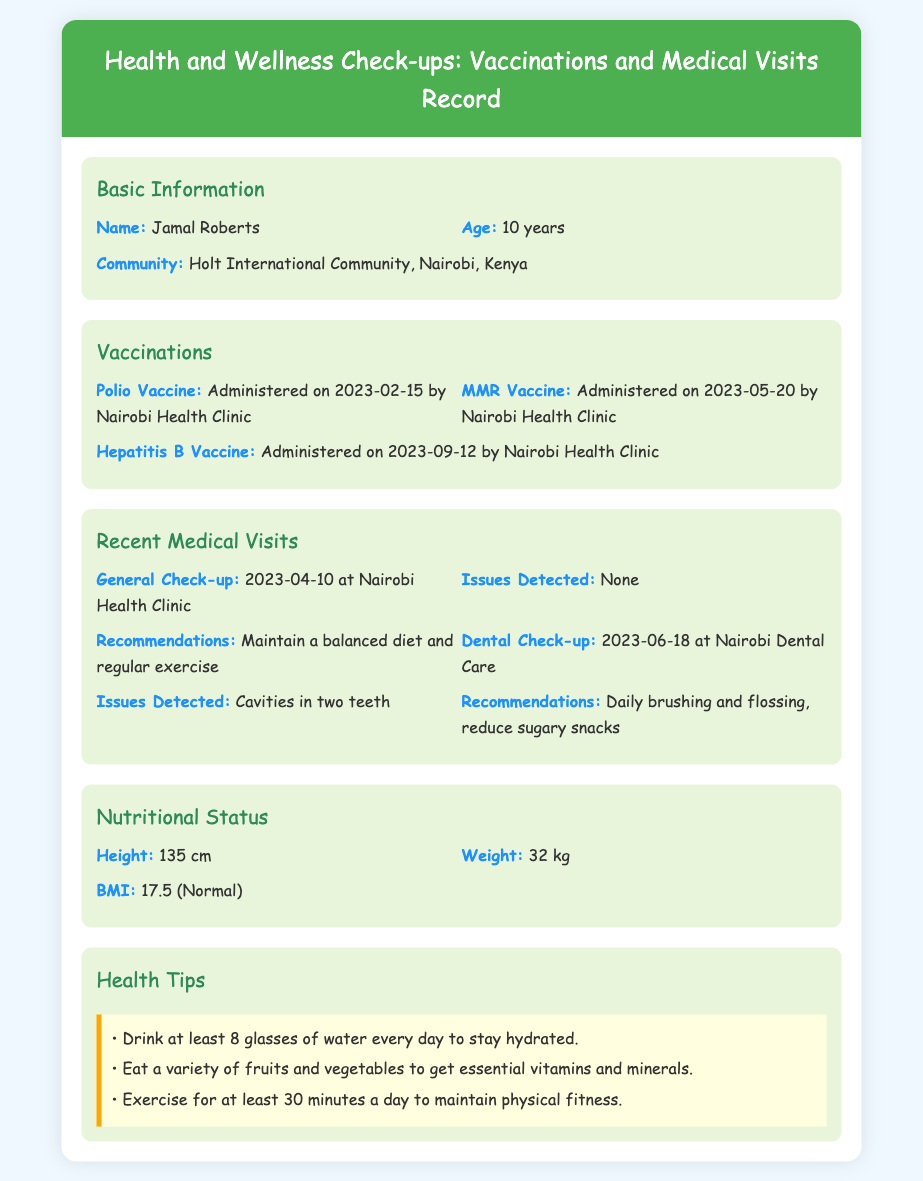What is the name of the child? The name of the child is provided in the Basic Information section of the document as "Jamal Roberts."
Answer: Jamal Roberts What is the age of the child? The age of the child is specified in the Basic Information section, listed as "10 years."
Answer: 10 years When was the Hepatitis B vaccine administered? The date of administration for the Hepatitis B vaccine is found in the Vaccinations section, which states "Administered on 2023-09-12."
Answer: 2023-09-12 What issues were detected during the dental check-up? The issues detected during the dental check-up are registered in the Recent Medical Visits section, noting "Cavities in two teeth."
Answer: Cavities in two teeth What is the recommended action for dental care? Recommendations for dental care are provided in the Recent Medical Visits section, suggesting "Daily brushing and flossing, reduce sugary snacks."
Answer: Daily brushing and flossing, reduce sugary snacks Which health clinic provided the general check-up? The health clinic where the general check-up took place is mentioned in the Recent Medical Visits section, identified as "Nairobi Health Clinic."
Answer: Nairobi Health Clinic What is the BMI of the child? The Body Mass Index (BMI) is mentioned in the Nutritional Status section of the document as "17.5 (Normal)."
Answer: 17.5 (Normal) What health tip suggests maintaining hydration? One of the health tips related to hydration is found in the Health Tips section, stating to "Drink at least 8 glasses of water every day to stay hydrated."
Answer: Drink at least 8 glasses of water every day to stay hydrated How many vaccinations have been administered? The total number of vaccinations listed in the Vaccinations section counts "3" vaccines: Polio, MMR, and Hepatitis B.
Answer: 3 